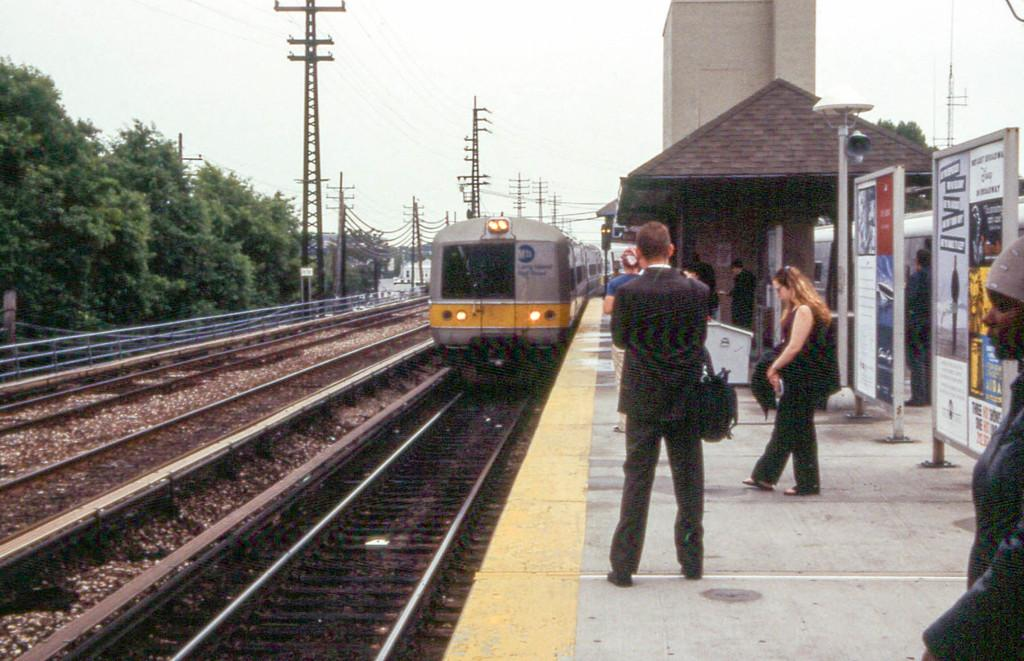What can be seen on the platform in the image? There are people standing on the platform in the image. What is located on the track? There is a locomotive on the track in the image. How many tracks are visible in the image? There are empty tracks visible in the image. What structures are related to the power supply in the image? Electric poles and electric cables are present in the image. What type of vegetation is in the image? Trees are in the image. What type of building is in the image? There is a shed in the image. What type of signage is present in the image? Advertisement boards are present in the image. What tall structure is in the image? There is a tower in the image. What part of the natural environment is visible in the image? The sky is visible in the image. What is the temperature of the people standing on the platform in the image? The temperature of the people standing on the platform cannot be determined from the image. What is the desire of the locomotive on the track in the image? Locomotives do not have desires, as they are inanimate objects. 